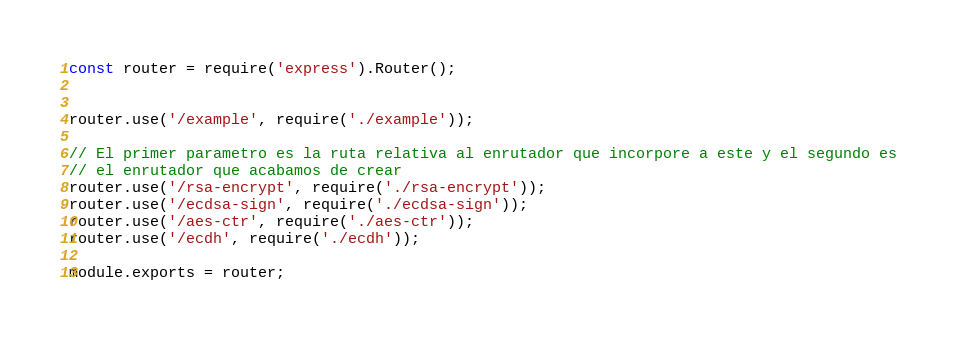Convert code to text. <code><loc_0><loc_0><loc_500><loc_500><_JavaScript_>const router = require('express').Router();


router.use('/example', require('./example'));

// El primer parametro es la ruta relativa al enrutador que incorpore a este y el segundo es
// el enrutador que acabamos de crear
router.use('/rsa-encrypt', require('./rsa-encrypt'));
router.use('/ecdsa-sign', require('./ecdsa-sign'));
router.use('/aes-ctr', require('./aes-ctr'));
router.use('/ecdh', require('./ecdh'));

module.exports = router;
</code> 